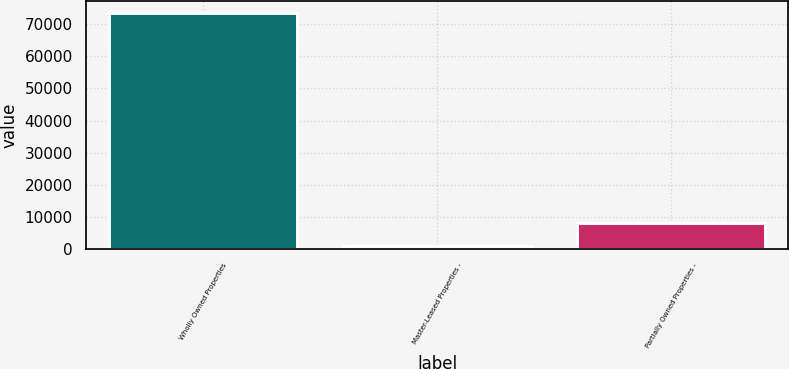Convert chart. <chart><loc_0><loc_0><loc_500><loc_500><bar_chart><fcel>Wholly Owned Properties<fcel>Master-Leased Properties -<fcel>Partially Owned Properties -<nl><fcel>73598<fcel>853<fcel>8127.5<nl></chart> 